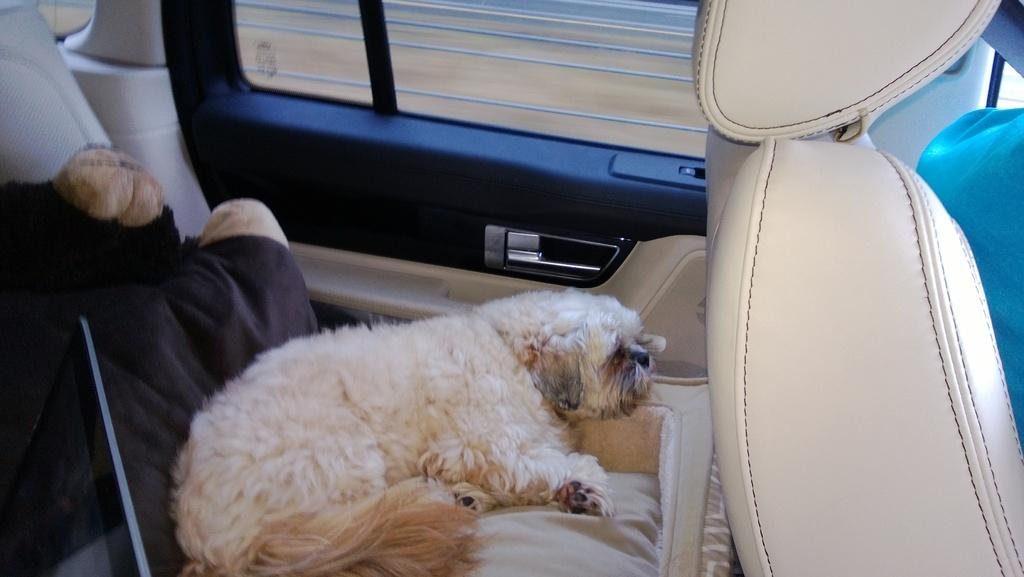What is the setting of the image? The image shows the inside of a vehicle. What can be seen on one of the seats in the vehicle? There is a dog on a seat in the vehicle. What type of window is present in the vehicle? There is a glass window in the vehicle. What type of material is present in the vehicle? Cloth is present in the vehicle. What type of leather is visible on the dog's collar in the image? There is no leather or collar visible on the dog in the image; it is simply sitting on the seat. 